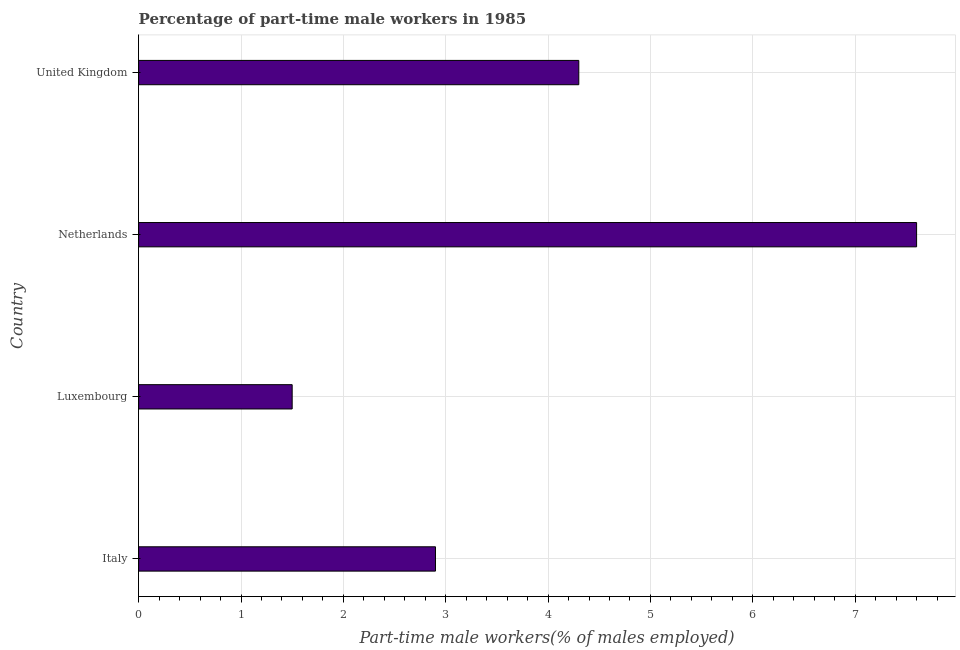Does the graph contain any zero values?
Provide a short and direct response. No. What is the title of the graph?
Keep it short and to the point. Percentage of part-time male workers in 1985. What is the label or title of the X-axis?
Offer a terse response. Part-time male workers(% of males employed). What is the label or title of the Y-axis?
Your answer should be compact. Country. What is the percentage of part-time male workers in Italy?
Your answer should be compact. 2.9. Across all countries, what is the maximum percentage of part-time male workers?
Your answer should be compact. 7.6. In which country was the percentage of part-time male workers minimum?
Provide a short and direct response. Luxembourg. What is the sum of the percentage of part-time male workers?
Your answer should be very brief. 16.3. What is the difference between the percentage of part-time male workers in Italy and Luxembourg?
Make the answer very short. 1.4. What is the average percentage of part-time male workers per country?
Give a very brief answer. 4.08. What is the median percentage of part-time male workers?
Ensure brevity in your answer.  3.6. In how many countries, is the percentage of part-time male workers greater than 6.2 %?
Make the answer very short. 1. What is the ratio of the percentage of part-time male workers in Italy to that in United Kingdom?
Your answer should be compact. 0.67. Is the difference between the percentage of part-time male workers in Luxembourg and Netherlands greater than the difference between any two countries?
Give a very brief answer. Yes. How many countries are there in the graph?
Make the answer very short. 4. What is the difference between two consecutive major ticks on the X-axis?
Make the answer very short. 1. What is the Part-time male workers(% of males employed) in Italy?
Offer a terse response. 2.9. What is the Part-time male workers(% of males employed) in Netherlands?
Give a very brief answer. 7.6. What is the Part-time male workers(% of males employed) in United Kingdom?
Your response must be concise. 4.3. What is the difference between the Part-time male workers(% of males employed) in Luxembourg and United Kingdom?
Offer a very short reply. -2.8. What is the difference between the Part-time male workers(% of males employed) in Netherlands and United Kingdom?
Ensure brevity in your answer.  3.3. What is the ratio of the Part-time male workers(% of males employed) in Italy to that in Luxembourg?
Make the answer very short. 1.93. What is the ratio of the Part-time male workers(% of males employed) in Italy to that in Netherlands?
Make the answer very short. 0.38. What is the ratio of the Part-time male workers(% of males employed) in Italy to that in United Kingdom?
Your response must be concise. 0.67. What is the ratio of the Part-time male workers(% of males employed) in Luxembourg to that in Netherlands?
Give a very brief answer. 0.2. What is the ratio of the Part-time male workers(% of males employed) in Luxembourg to that in United Kingdom?
Make the answer very short. 0.35. What is the ratio of the Part-time male workers(% of males employed) in Netherlands to that in United Kingdom?
Provide a succinct answer. 1.77. 